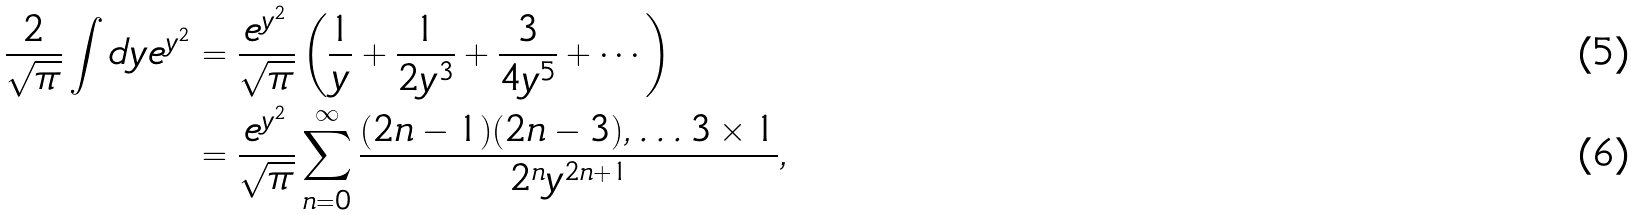Convert formula to latex. <formula><loc_0><loc_0><loc_500><loc_500>\frac { 2 } { \sqrt { \pi } } \int d y e ^ { y ^ { 2 } } & = \frac { e ^ { y ^ { 2 } } } { \sqrt { \pi } } \left ( \frac { 1 } { y } + \frac { 1 } { 2 y ^ { 3 } } + \frac { 3 } { 4 y ^ { 5 } } + \cdots \right ) \\ & = \frac { e ^ { y ^ { 2 } } } { \sqrt { \pi } } \sum _ { n = 0 } ^ { \infty } \frac { ( 2 n - 1 ) ( 2 n - 3 ) , \dots 3 \times 1 } { 2 ^ { n } y ^ { 2 n + 1 } } ,</formula> 